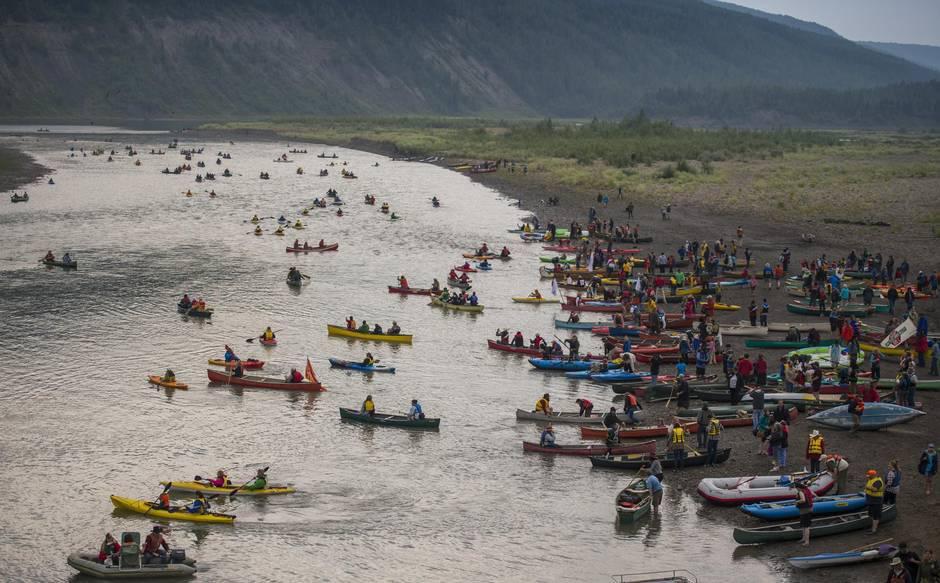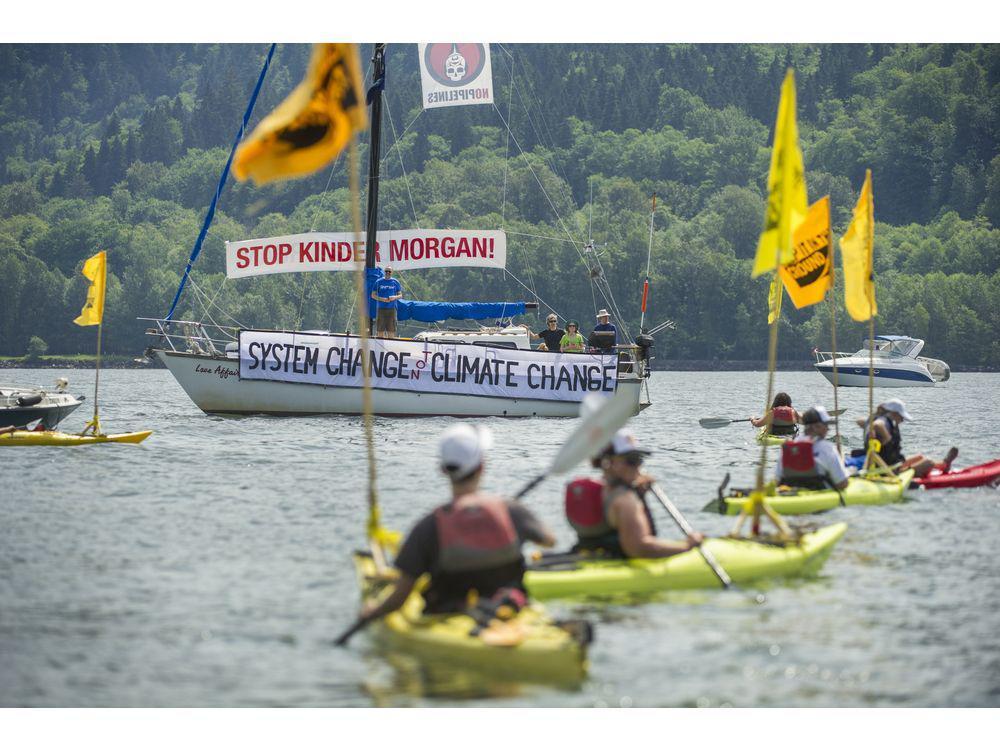The first image is the image on the left, the second image is the image on the right. Analyze the images presented: Is the assertion "Each image shows just one boat in the foreground." valid? Answer yes or no. No. The first image is the image on the left, the second image is the image on the right. For the images displayed, is the sentence "One of the images shows an American Indian Movement flag with black, yellow, white, and red stripes and a red logo." factually correct? Answer yes or no. No. 